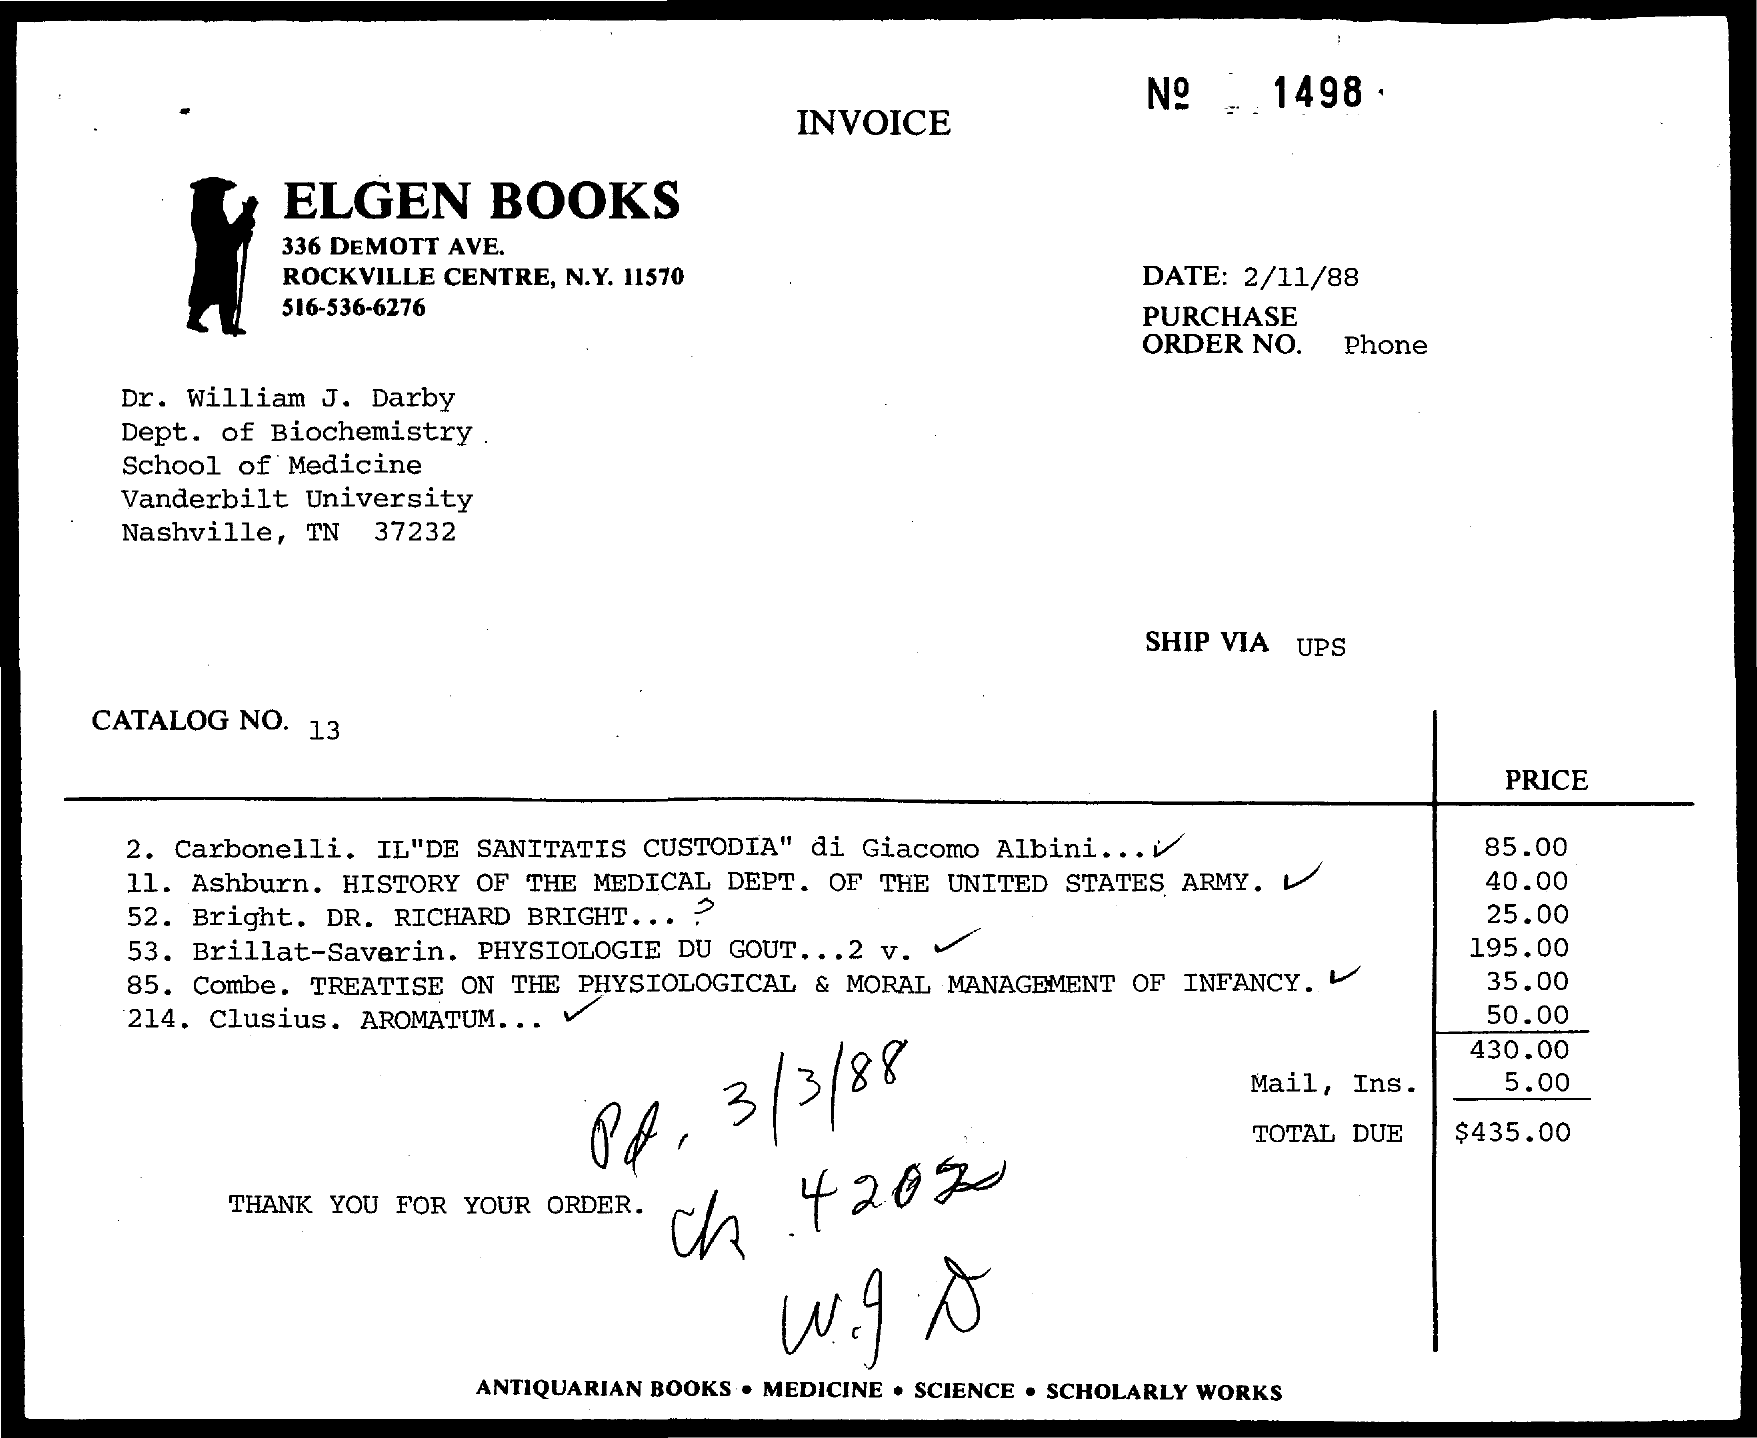Identify some key points in this picture. The name of the bookstore mentioned in the given invoice is Elgen Books. Dr. William J. Darby is affiliated with Vanderbilt University. 